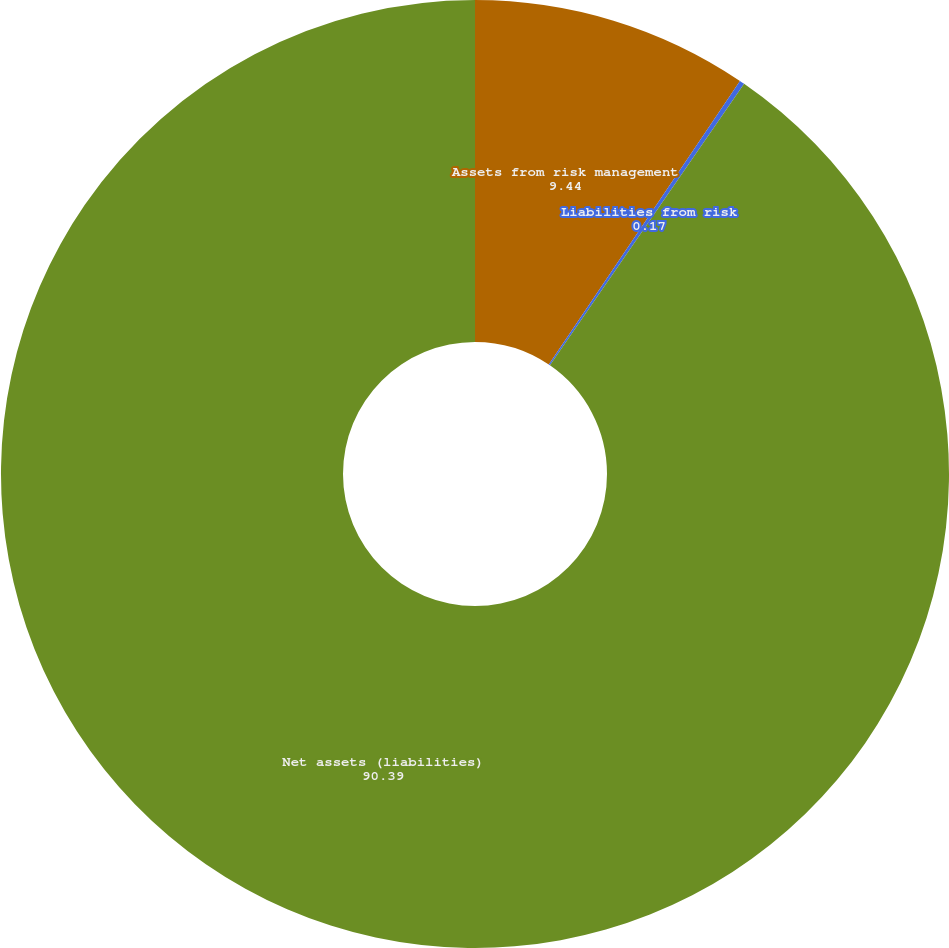Convert chart. <chart><loc_0><loc_0><loc_500><loc_500><pie_chart><fcel>Assets from risk management<fcel>Liabilities from risk<fcel>Net assets (liabilities)<nl><fcel>9.44%<fcel>0.17%<fcel>90.39%<nl></chart> 